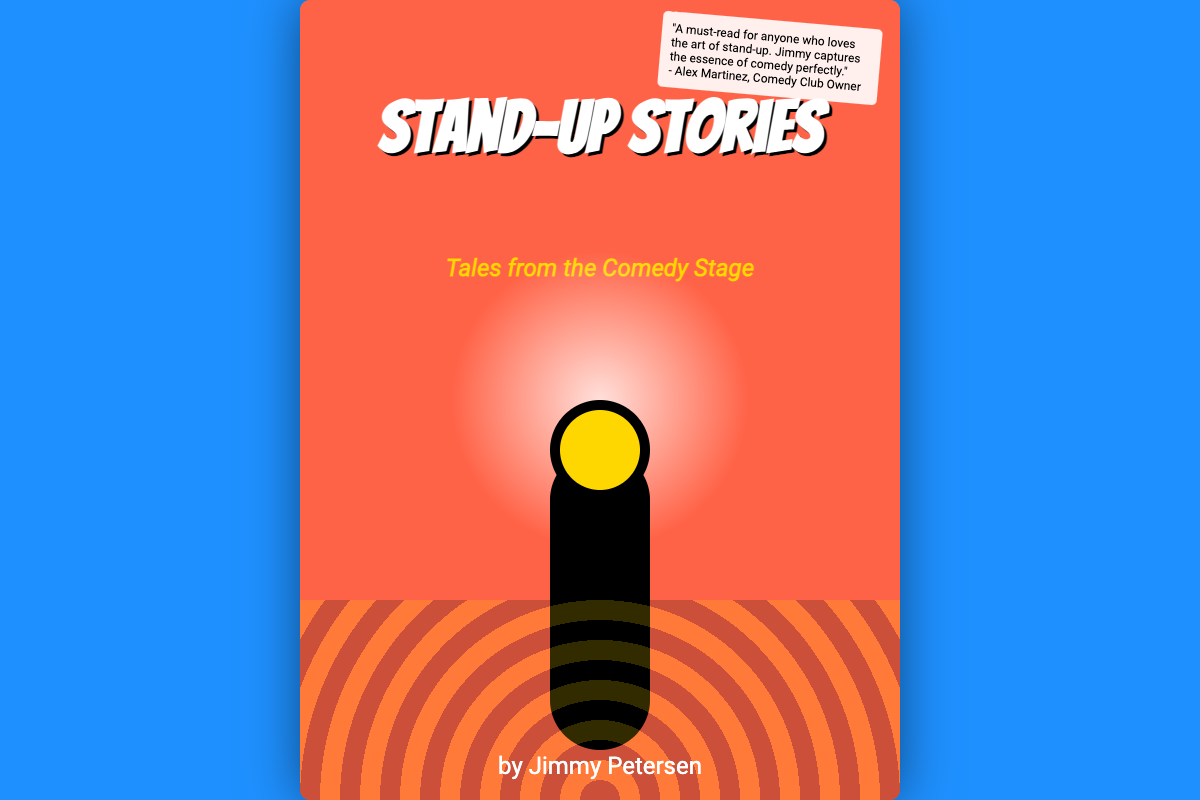What is the title of the book? The title is prominently displayed on the cover in large text.
Answer: Stand-Up Stories Who is the author of the book? The author's name is located at the bottom of the cover.
Answer: Jimmy Petersen What is the subtitle of the book? The subtitle is presented under the title in smaller text.
Answer: Tales from the Comedy Stage What color is the background of the book cover? The background color is part of the cover styling.
Answer: #FF6347 How many testimonials are on the cover? There is only one testimonial visible on the cover design.
Answer: One What does the testimonial highlight? The testimonial mentions the quality and essence of a particular art form in the book.
Answer: A must-read for anyone who loves the art of stand-up What imagery is used to represent the comedy theme? The cover features specific visual elements that symbolize comedy.
Answer: A retro microphone What is the focal point feature of the cover? The design has a highlighted element at the center which draws attention.
Answer: Spotlighted microphone What design element represents the audience? The cover uses a specific graphic to depict the audience's reaction.
Answer: Lively audience laughing 